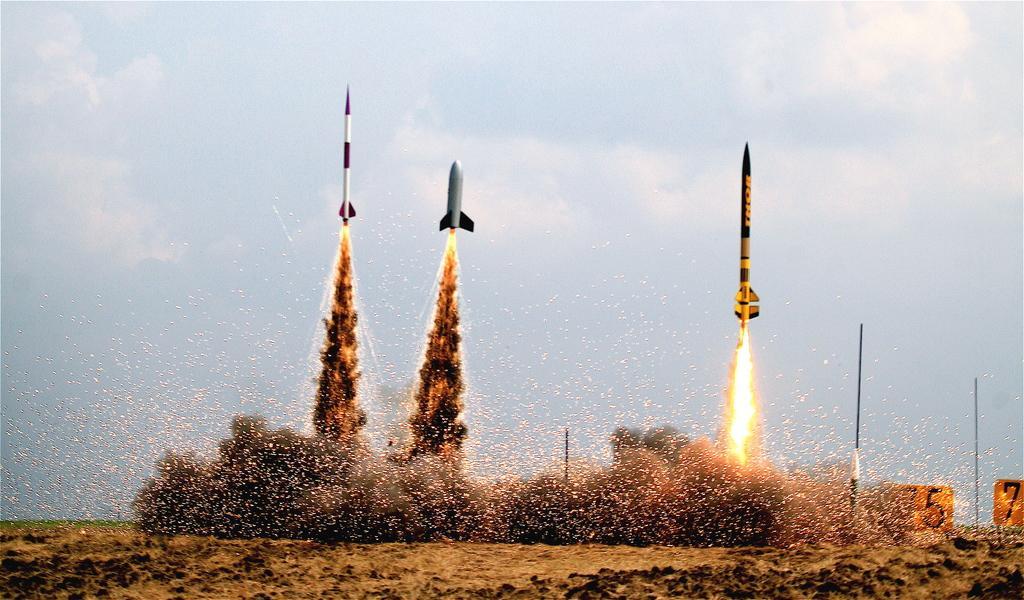Describe this image in one or two sentences. In this image there are three rockets going to the air by emitting smoke, fire, at the top there is the sky, in the middle there are some poles visible. 